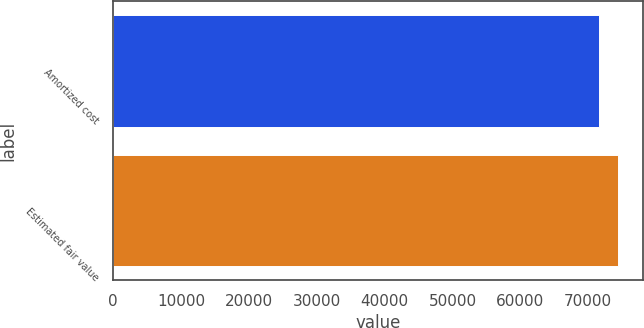<chart> <loc_0><loc_0><loc_500><loc_500><bar_chart><fcel>Amortized cost<fcel>Estimated fair value<nl><fcel>71590<fcel>74364<nl></chart> 